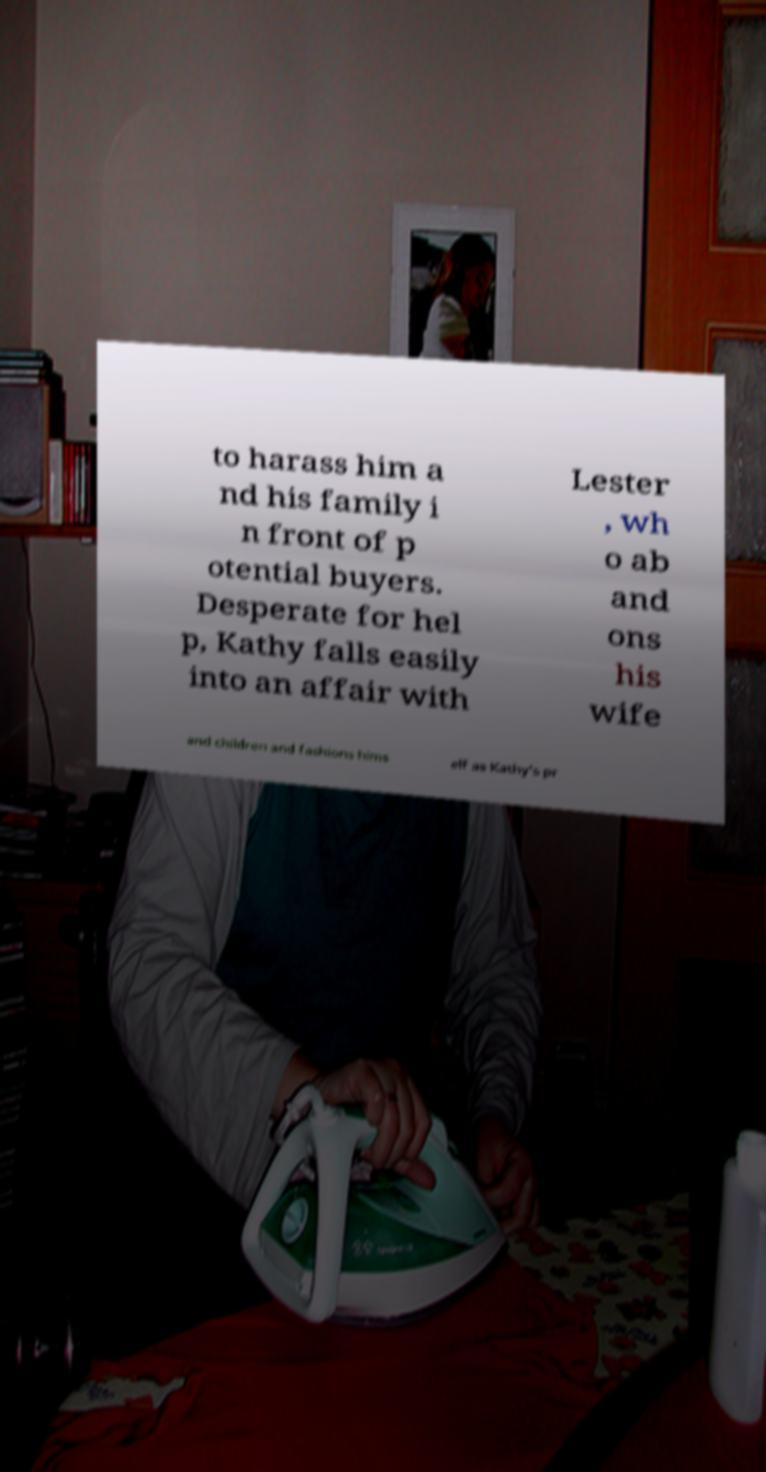Could you extract and type out the text from this image? to harass him a nd his family i n front of p otential buyers. Desperate for hel p, Kathy falls easily into an affair with Lester , wh o ab and ons his wife and children and fashions hims elf as Kathy's pr 